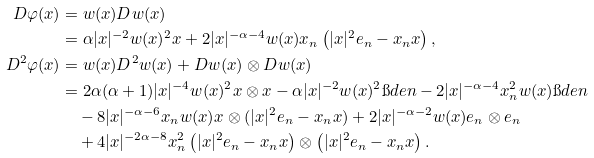Convert formula to latex. <formula><loc_0><loc_0><loc_500><loc_500>D \varphi ( x ) & = w ( x ) D w ( x ) \\ & = \alpha | x | ^ { - 2 } w ( x ) ^ { 2 } x + 2 | x | ^ { - \alpha - 4 } w ( x ) x _ { n } \left ( | x | ^ { 2 } e _ { n } - x _ { n } x \right ) , \\ D ^ { 2 } \varphi ( x ) & = w ( x ) D ^ { 2 } w ( x ) + D w ( x ) \otimes D w ( x ) \\ & = 2 \alpha ( \alpha + 1 ) | x | ^ { - 4 } w ( x ) ^ { 2 } x \otimes x - \alpha | x | ^ { - 2 } w ( x ) ^ { 2 } \i d e n - 2 | x | ^ { - \alpha - 4 } x _ { n } ^ { 2 } w ( x ) \i d e n \\ & \quad - 8 | x | ^ { - \alpha - 6 } x _ { n } w ( x ) x \otimes ( | x | ^ { 2 } e _ { n } - x _ { n } x ) + 2 | x | ^ { - \alpha - 2 } w ( x ) e _ { n } \otimes e _ { n } \\ & \quad + 4 | x | ^ { - 2 \alpha - 8 } x _ { n } ^ { 2 } \left ( | x | ^ { 2 } e _ { n } - x _ { n } x \right ) \otimes \left ( | x | ^ { 2 } e _ { n } - x _ { n } x \right ) .</formula> 